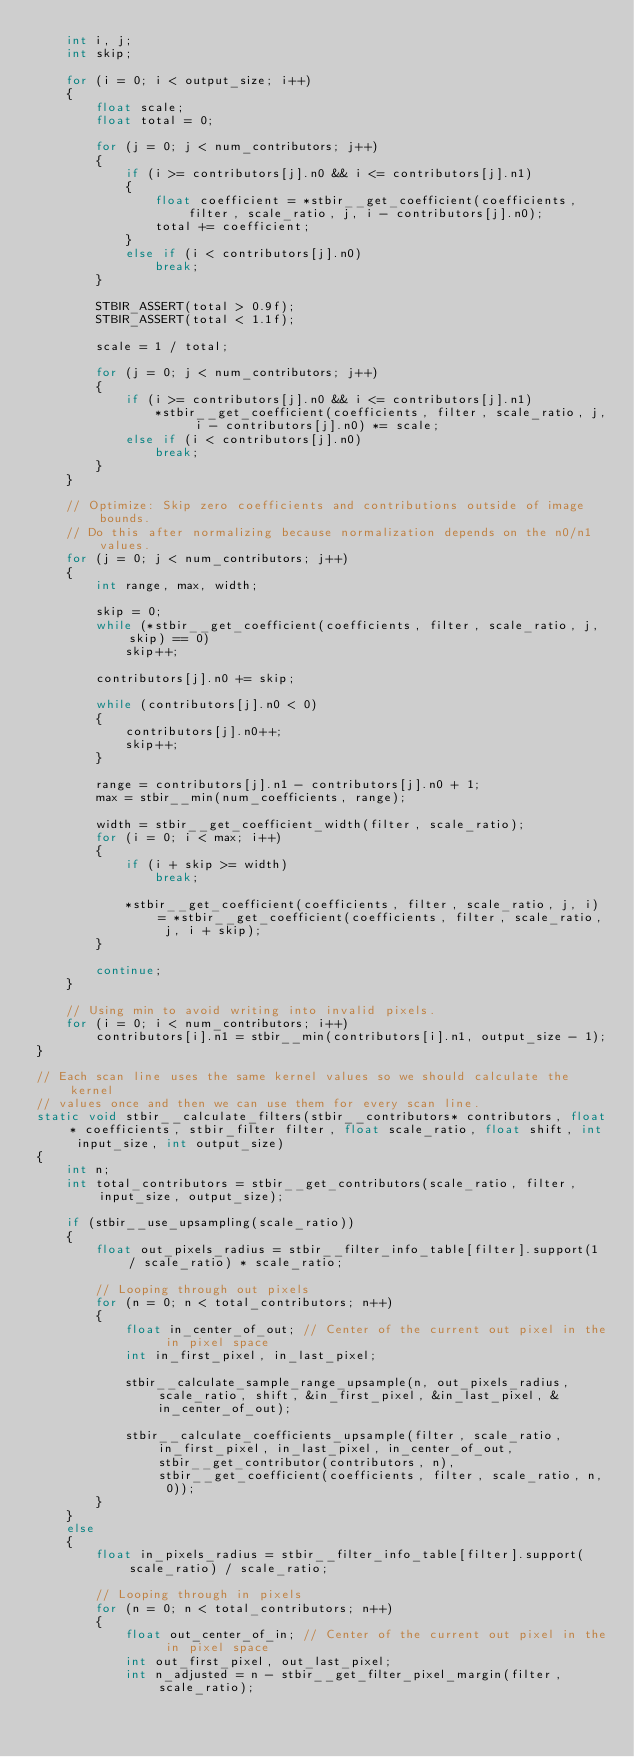<code> <loc_0><loc_0><loc_500><loc_500><_C_>    int i, j;
    int skip;

    for (i = 0; i < output_size; i++)
    {
        float scale;
        float total = 0;

        for (j = 0; j < num_contributors; j++)
        {
            if (i >= contributors[j].n0 && i <= contributors[j].n1)
            {
                float coefficient = *stbir__get_coefficient(coefficients, filter, scale_ratio, j, i - contributors[j].n0);
                total += coefficient;
            }
            else if (i < contributors[j].n0)
                break;
        }

        STBIR_ASSERT(total > 0.9f);
        STBIR_ASSERT(total < 1.1f);

        scale = 1 / total;

        for (j = 0; j < num_contributors; j++)
        {
            if (i >= contributors[j].n0 && i <= contributors[j].n1)
                *stbir__get_coefficient(coefficients, filter, scale_ratio, j, i - contributors[j].n0) *= scale;
            else if (i < contributors[j].n0)
                break;
        }
    }

    // Optimize: Skip zero coefficients and contributions outside of image bounds.
    // Do this after normalizing because normalization depends on the n0/n1 values.
    for (j = 0; j < num_contributors; j++)
    {
        int range, max, width;

        skip = 0;
        while (*stbir__get_coefficient(coefficients, filter, scale_ratio, j, skip) == 0)
            skip++;

        contributors[j].n0 += skip;

        while (contributors[j].n0 < 0)
        {
            contributors[j].n0++;
            skip++;
        }

        range = contributors[j].n1 - contributors[j].n0 + 1;
        max = stbir__min(num_coefficients, range);

        width = stbir__get_coefficient_width(filter, scale_ratio);
        for (i = 0; i < max; i++)
        {
            if (i + skip >= width)
                break;

            *stbir__get_coefficient(coefficients, filter, scale_ratio, j, i) = *stbir__get_coefficient(coefficients, filter, scale_ratio, j, i + skip);
        }

        continue;
    }

    // Using min to avoid writing into invalid pixels.
    for (i = 0; i < num_contributors; i++)
        contributors[i].n1 = stbir__min(contributors[i].n1, output_size - 1);
}

// Each scan line uses the same kernel values so we should calculate the kernel
// values once and then we can use them for every scan line.
static void stbir__calculate_filters(stbir__contributors* contributors, float* coefficients, stbir_filter filter, float scale_ratio, float shift, int input_size, int output_size)
{
    int n;
    int total_contributors = stbir__get_contributors(scale_ratio, filter, input_size, output_size);

    if (stbir__use_upsampling(scale_ratio))
    {
        float out_pixels_radius = stbir__filter_info_table[filter].support(1 / scale_ratio) * scale_ratio;

        // Looping through out pixels
        for (n = 0; n < total_contributors; n++)
        {
            float in_center_of_out; // Center of the current out pixel in the in pixel space
            int in_first_pixel, in_last_pixel;

            stbir__calculate_sample_range_upsample(n, out_pixels_radius, scale_ratio, shift, &in_first_pixel, &in_last_pixel, &in_center_of_out);

            stbir__calculate_coefficients_upsample(filter, scale_ratio, in_first_pixel, in_last_pixel, in_center_of_out, stbir__get_contributor(contributors, n), stbir__get_coefficient(coefficients, filter, scale_ratio, n, 0));
        }
    }
    else
    {
        float in_pixels_radius = stbir__filter_info_table[filter].support(scale_ratio) / scale_ratio;

        // Looping through in pixels
        for (n = 0; n < total_contributors; n++)
        {
            float out_center_of_in; // Center of the current out pixel in the in pixel space
            int out_first_pixel, out_last_pixel;
            int n_adjusted = n - stbir__get_filter_pixel_margin(filter, scale_ratio);
</code> 